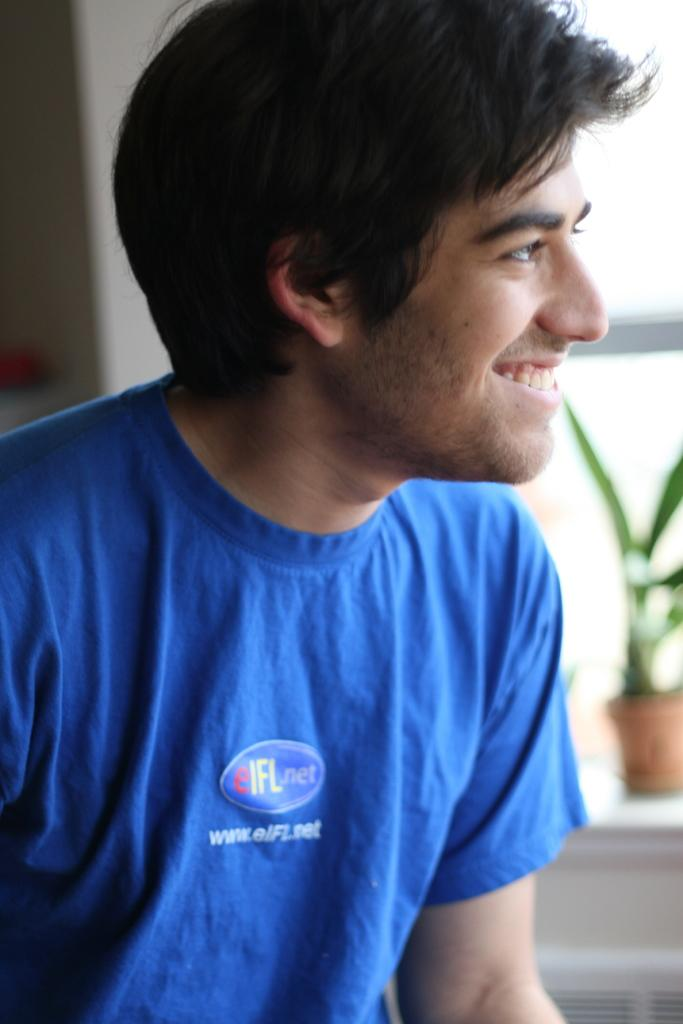What is the main subject of the image? There is a man in the image. What is the man wearing in the image? The man is wearing a blue shirt. What is the man's facial expression in the image? The man is smiling. In which direction is the man looking in the image? The man is looking towards his right. How would you describe the background of the man in the image? The background of the man is blurred. What type of ship can be seen in the background of the image? There is no ship present in the background of the image. What channel is the man watching on the television in the image? There is no television or channel mentioned in the image; it only features a man. 